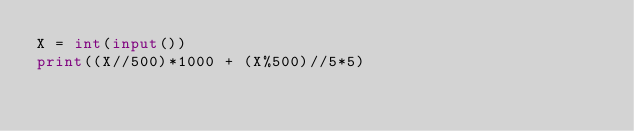Convert code to text. <code><loc_0><loc_0><loc_500><loc_500><_Python_>X = int(input())
print((X//500)*1000 + (X%500)//5*5)</code> 